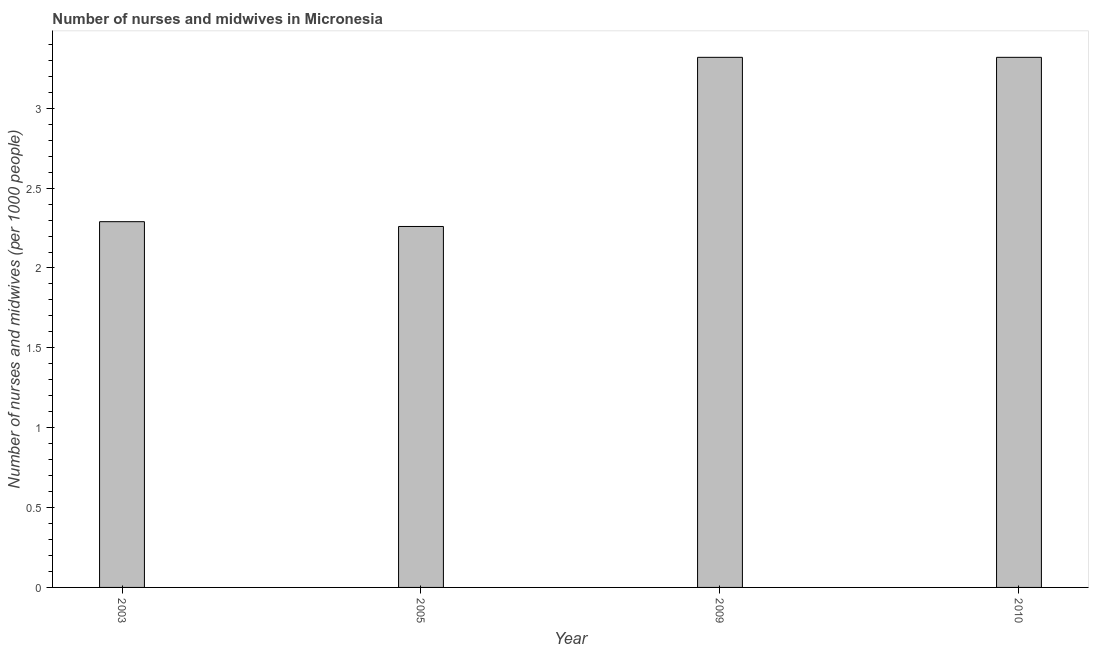Does the graph contain any zero values?
Your answer should be very brief. No. Does the graph contain grids?
Your answer should be very brief. No. What is the title of the graph?
Make the answer very short. Number of nurses and midwives in Micronesia. What is the label or title of the X-axis?
Your response must be concise. Year. What is the label or title of the Y-axis?
Your response must be concise. Number of nurses and midwives (per 1000 people). What is the number of nurses and midwives in 2003?
Make the answer very short. 2.29. Across all years, what is the maximum number of nurses and midwives?
Give a very brief answer. 3.32. Across all years, what is the minimum number of nurses and midwives?
Offer a terse response. 2.26. In which year was the number of nurses and midwives maximum?
Offer a terse response. 2009. What is the sum of the number of nurses and midwives?
Provide a short and direct response. 11.19. What is the difference between the number of nurses and midwives in 2003 and 2010?
Keep it short and to the point. -1.03. What is the average number of nurses and midwives per year?
Your answer should be compact. 2.8. What is the median number of nurses and midwives?
Make the answer very short. 2.8. What is the ratio of the number of nurses and midwives in 2003 to that in 2010?
Your answer should be very brief. 0.69. What is the difference between the highest and the second highest number of nurses and midwives?
Your answer should be compact. 0. Is the sum of the number of nurses and midwives in 2009 and 2010 greater than the maximum number of nurses and midwives across all years?
Give a very brief answer. Yes. What is the difference between the highest and the lowest number of nurses and midwives?
Give a very brief answer. 1.06. In how many years, is the number of nurses and midwives greater than the average number of nurses and midwives taken over all years?
Your answer should be compact. 2. How many bars are there?
Ensure brevity in your answer.  4. Are the values on the major ticks of Y-axis written in scientific E-notation?
Ensure brevity in your answer.  No. What is the Number of nurses and midwives (per 1000 people) in 2003?
Your response must be concise. 2.29. What is the Number of nurses and midwives (per 1000 people) in 2005?
Provide a succinct answer. 2.26. What is the Number of nurses and midwives (per 1000 people) of 2009?
Offer a terse response. 3.32. What is the Number of nurses and midwives (per 1000 people) in 2010?
Give a very brief answer. 3.32. What is the difference between the Number of nurses and midwives (per 1000 people) in 2003 and 2005?
Give a very brief answer. 0.03. What is the difference between the Number of nurses and midwives (per 1000 people) in 2003 and 2009?
Offer a terse response. -1.03. What is the difference between the Number of nurses and midwives (per 1000 people) in 2003 and 2010?
Your answer should be compact. -1.03. What is the difference between the Number of nurses and midwives (per 1000 people) in 2005 and 2009?
Your answer should be very brief. -1.06. What is the difference between the Number of nurses and midwives (per 1000 people) in 2005 and 2010?
Offer a terse response. -1.06. What is the difference between the Number of nurses and midwives (per 1000 people) in 2009 and 2010?
Keep it short and to the point. 0. What is the ratio of the Number of nurses and midwives (per 1000 people) in 2003 to that in 2009?
Your response must be concise. 0.69. What is the ratio of the Number of nurses and midwives (per 1000 people) in 2003 to that in 2010?
Offer a terse response. 0.69. What is the ratio of the Number of nurses and midwives (per 1000 people) in 2005 to that in 2009?
Your answer should be very brief. 0.68. What is the ratio of the Number of nurses and midwives (per 1000 people) in 2005 to that in 2010?
Keep it short and to the point. 0.68. What is the ratio of the Number of nurses and midwives (per 1000 people) in 2009 to that in 2010?
Your answer should be very brief. 1. 